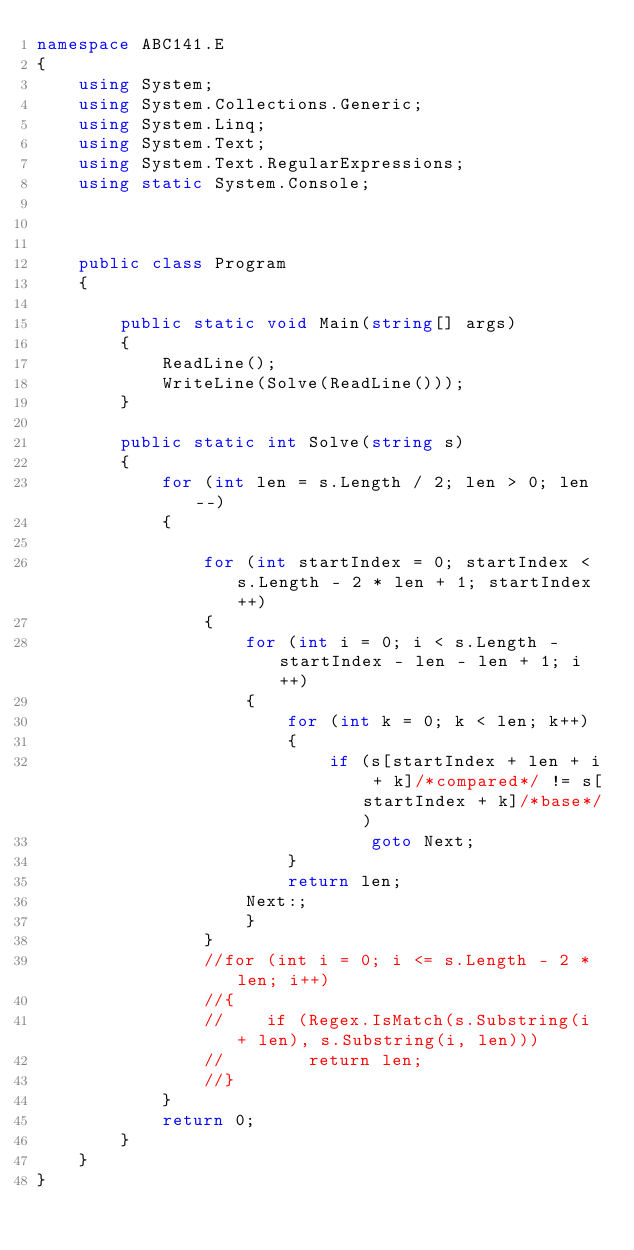Convert code to text. <code><loc_0><loc_0><loc_500><loc_500><_C#_>namespace ABC141.E
{
    using System;
    using System.Collections.Generic;
    using System.Linq;
    using System.Text;
    using System.Text.RegularExpressions;
    using static System.Console;



    public class Program
    {

        public static void Main(string[] args)
        {
            ReadLine();
            WriteLine(Solve(ReadLine()));
        }

        public static int Solve(string s)
        {
            for (int len = s.Length / 2; len > 0; len--)
            {

                for (int startIndex = 0; startIndex < s.Length - 2 * len + 1; startIndex++)
                {
                    for (int i = 0; i < s.Length - startIndex - len - len + 1; i++)
                    {
                        for (int k = 0; k < len; k++)
                        {
                            if (s[startIndex + len + i + k]/*compared*/ != s[startIndex + k]/*base*/)
                                goto Next;
                        }
                        return len;
                    Next:;
                    }
                }
                //for (int i = 0; i <= s.Length - 2 * len; i++)
                //{
                //    if (Regex.IsMatch(s.Substring(i + len), s.Substring(i, len)))
                //        return len;
                //}
            }
            return 0;
        }
    }
}
</code> 